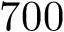Convert formula to latex. <formula><loc_0><loc_0><loc_500><loc_500>7 0 0</formula> 